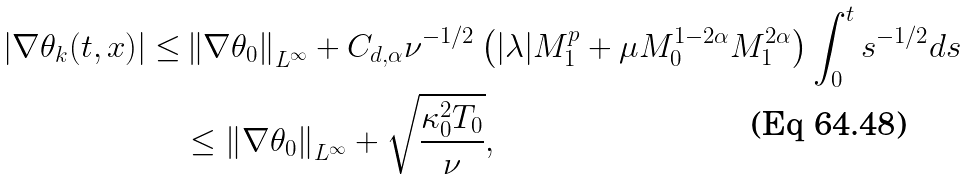<formula> <loc_0><loc_0><loc_500><loc_500>| \nabla \theta _ { k } ( t , x ) | \leq & \left \| \nabla \theta _ { 0 } \right \| _ { L ^ { \infty } } + C _ { d , \alpha } \nu ^ { - 1 / 2 } \left ( | \lambda | M _ { 1 } ^ { p } + \mu M _ { 0 } ^ { 1 - 2 \alpha } M _ { 1 } ^ { 2 \alpha } \right ) \int _ { 0 } ^ { t } s ^ { - 1 / 2 } d s \\ & \leq \left \| \nabla \theta _ { 0 } \right \| _ { L ^ { \infty } } + \sqrt { \frac { \kappa _ { 0 } ^ { 2 } T _ { 0 } } { \nu } } ,</formula> 